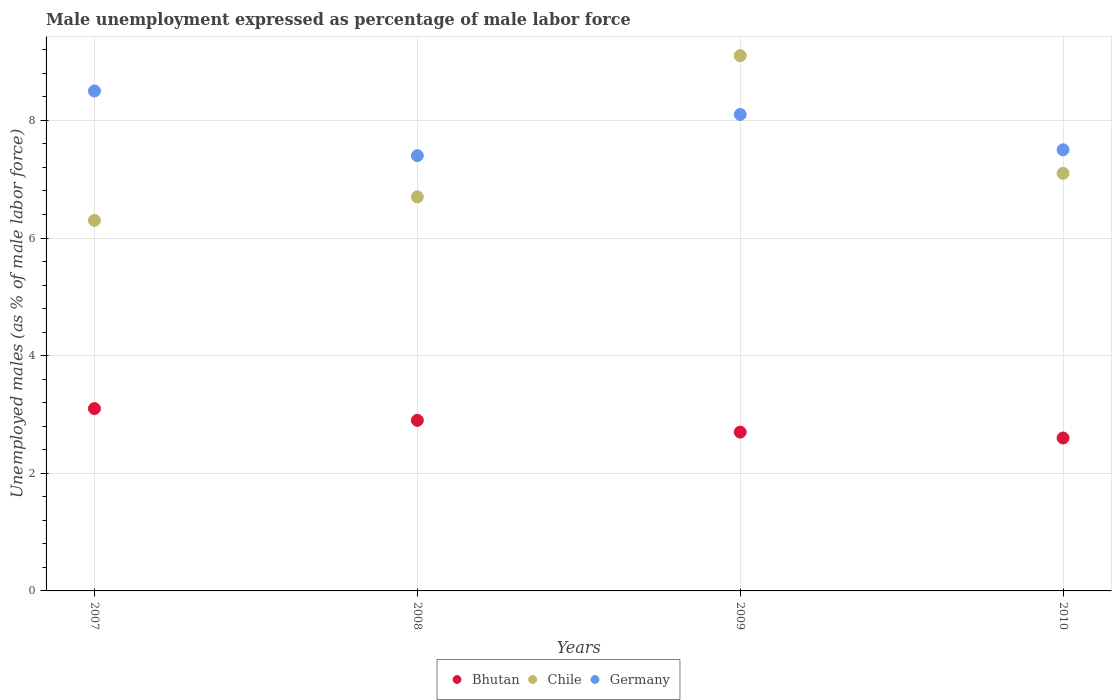Is the number of dotlines equal to the number of legend labels?
Provide a succinct answer. Yes. Across all years, what is the maximum unemployment in males in in Chile?
Your answer should be very brief. 9.1. Across all years, what is the minimum unemployment in males in in Bhutan?
Offer a very short reply. 2.6. What is the total unemployment in males in in Bhutan in the graph?
Your response must be concise. 11.3. What is the difference between the unemployment in males in in Bhutan in 2007 and that in 2009?
Keep it short and to the point. 0.4. What is the difference between the unemployment in males in in Bhutan in 2010 and the unemployment in males in in Germany in 2008?
Provide a succinct answer. -4.8. What is the average unemployment in males in in Chile per year?
Provide a short and direct response. 7.3. In the year 2010, what is the difference between the unemployment in males in in Germany and unemployment in males in in Bhutan?
Ensure brevity in your answer.  4.9. In how many years, is the unemployment in males in in Bhutan greater than 6 %?
Make the answer very short. 0. What is the ratio of the unemployment in males in in Germany in 2007 to that in 2009?
Give a very brief answer. 1.05. Is the unemployment in males in in Germany in 2007 less than that in 2008?
Give a very brief answer. No. Is the difference between the unemployment in males in in Germany in 2008 and 2009 greater than the difference between the unemployment in males in in Bhutan in 2008 and 2009?
Offer a terse response. No. What is the difference between the highest and the second highest unemployment in males in in Germany?
Provide a short and direct response. 0.4. What is the difference between the highest and the lowest unemployment in males in in Germany?
Ensure brevity in your answer.  1.1. In how many years, is the unemployment in males in in Germany greater than the average unemployment in males in in Germany taken over all years?
Your response must be concise. 2. Is the sum of the unemployment in males in in Bhutan in 2007 and 2010 greater than the maximum unemployment in males in in Chile across all years?
Offer a terse response. No. Is it the case that in every year, the sum of the unemployment in males in in Germany and unemployment in males in in Chile  is greater than the unemployment in males in in Bhutan?
Your response must be concise. Yes. Does the unemployment in males in in Germany monotonically increase over the years?
Your answer should be very brief. No. Is the unemployment in males in in Bhutan strictly less than the unemployment in males in in Chile over the years?
Your answer should be very brief. Yes. How many dotlines are there?
Keep it short and to the point. 3. What is the difference between two consecutive major ticks on the Y-axis?
Ensure brevity in your answer.  2. How are the legend labels stacked?
Your answer should be very brief. Horizontal. What is the title of the graph?
Offer a terse response. Male unemployment expressed as percentage of male labor force. What is the label or title of the X-axis?
Give a very brief answer. Years. What is the label or title of the Y-axis?
Ensure brevity in your answer.  Unemployed males (as % of male labor force). What is the Unemployed males (as % of male labor force) of Bhutan in 2007?
Give a very brief answer. 3.1. What is the Unemployed males (as % of male labor force) of Chile in 2007?
Offer a very short reply. 6.3. What is the Unemployed males (as % of male labor force) of Germany in 2007?
Offer a terse response. 8.5. What is the Unemployed males (as % of male labor force) of Bhutan in 2008?
Provide a short and direct response. 2.9. What is the Unemployed males (as % of male labor force) of Chile in 2008?
Ensure brevity in your answer.  6.7. What is the Unemployed males (as % of male labor force) in Germany in 2008?
Your response must be concise. 7.4. What is the Unemployed males (as % of male labor force) of Bhutan in 2009?
Your answer should be very brief. 2.7. What is the Unemployed males (as % of male labor force) of Chile in 2009?
Provide a succinct answer. 9.1. What is the Unemployed males (as % of male labor force) of Germany in 2009?
Keep it short and to the point. 8.1. What is the Unemployed males (as % of male labor force) of Bhutan in 2010?
Provide a short and direct response. 2.6. What is the Unemployed males (as % of male labor force) of Chile in 2010?
Make the answer very short. 7.1. Across all years, what is the maximum Unemployed males (as % of male labor force) in Bhutan?
Keep it short and to the point. 3.1. Across all years, what is the maximum Unemployed males (as % of male labor force) of Chile?
Your answer should be compact. 9.1. Across all years, what is the maximum Unemployed males (as % of male labor force) in Germany?
Offer a very short reply. 8.5. Across all years, what is the minimum Unemployed males (as % of male labor force) of Bhutan?
Offer a terse response. 2.6. Across all years, what is the minimum Unemployed males (as % of male labor force) in Chile?
Make the answer very short. 6.3. Across all years, what is the minimum Unemployed males (as % of male labor force) of Germany?
Give a very brief answer. 7.4. What is the total Unemployed males (as % of male labor force) of Chile in the graph?
Provide a succinct answer. 29.2. What is the total Unemployed males (as % of male labor force) of Germany in the graph?
Offer a terse response. 31.5. What is the difference between the Unemployed males (as % of male labor force) of Bhutan in 2007 and that in 2008?
Your response must be concise. 0.2. What is the difference between the Unemployed males (as % of male labor force) in Germany in 2007 and that in 2008?
Your answer should be very brief. 1.1. What is the difference between the Unemployed males (as % of male labor force) of Chile in 2007 and that in 2009?
Offer a very short reply. -2.8. What is the difference between the Unemployed males (as % of male labor force) of Germany in 2007 and that in 2010?
Offer a terse response. 1. What is the difference between the Unemployed males (as % of male labor force) in Germany in 2008 and that in 2009?
Make the answer very short. -0.7. What is the difference between the Unemployed males (as % of male labor force) of Bhutan in 2009 and that in 2010?
Make the answer very short. 0.1. What is the difference between the Unemployed males (as % of male labor force) of Chile in 2009 and that in 2010?
Make the answer very short. 2. What is the difference between the Unemployed males (as % of male labor force) of Chile in 2007 and the Unemployed males (as % of male labor force) of Germany in 2008?
Provide a succinct answer. -1.1. What is the difference between the Unemployed males (as % of male labor force) of Bhutan in 2007 and the Unemployed males (as % of male labor force) of Germany in 2009?
Offer a terse response. -5. What is the difference between the Unemployed males (as % of male labor force) of Chile in 2007 and the Unemployed males (as % of male labor force) of Germany in 2009?
Offer a terse response. -1.8. What is the difference between the Unemployed males (as % of male labor force) of Bhutan in 2007 and the Unemployed males (as % of male labor force) of Germany in 2010?
Give a very brief answer. -4.4. What is the difference between the Unemployed males (as % of male labor force) in Chile in 2007 and the Unemployed males (as % of male labor force) in Germany in 2010?
Your response must be concise. -1.2. What is the difference between the Unemployed males (as % of male labor force) in Bhutan in 2009 and the Unemployed males (as % of male labor force) in Chile in 2010?
Offer a very short reply. -4.4. What is the difference between the Unemployed males (as % of male labor force) in Chile in 2009 and the Unemployed males (as % of male labor force) in Germany in 2010?
Give a very brief answer. 1.6. What is the average Unemployed males (as % of male labor force) in Bhutan per year?
Ensure brevity in your answer.  2.83. What is the average Unemployed males (as % of male labor force) in Germany per year?
Provide a succinct answer. 7.88. In the year 2007, what is the difference between the Unemployed males (as % of male labor force) of Bhutan and Unemployed males (as % of male labor force) of Chile?
Provide a short and direct response. -3.2. In the year 2007, what is the difference between the Unemployed males (as % of male labor force) of Bhutan and Unemployed males (as % of male labor force) of Germany?
Your answer should be very brief. -5.4. In the year 2007, what is the difference between the Unemployed males (as % of male labor force) of Chile and Unemployed males (as % of male labor force) of Germany?
Provide a short and direct response. -2.2. In the year 2008, what is the difference between the Unemployed males (as % of male labor force) of Bhutan and Unemployed males (as % of male labor force) of Chile?
Your answer should be very brief. -3.8. In the year 2008, what is the difference between the Unemployed males (as % of male labor force) of Bhutan and Unemployed males (as % of male labor force) of Germany?
Provide a short and direct response. -4.5. In the year 2008, what is the difference between the Unemployed males (as % of male labor force) in Chile and Unemployed males (as % of male labor force) in Germany?
Offer a terse response. -0.7. In the year 2010, what is the difference between the Unemployed males (as % of male labor force) of Bhutan and Unemployed males (as % of male labor force) of Chile?
Offer a terse response. -4.5. In the year 2010, what is the difference between the Unemployed males (as % of male labor force) in Chile and Unemployed males (as % of male labor force) in Germany?
Offer a very short reply. -0.4. What is the ratio of the Unemployed males (as % of male labor force) of Bhutan in 2007 to that in 2008?
Your answer should be very brief. 1.07. What is the ratio of the Unemployed males (as % of male labor force) in Chile in 2007 to that in 2008?
Make the answer very short. 0.94. What is the ratio of the Unemployed males (as % of male labor force) in Germany in 2007 to that in 2008?
Offer a very short reply. 1.15. What is the ratio of the Unemployed males (as % of male labor force) of Bhutan in 2007 to that in 2009?
Your answer should be very brief. 1.15. What is the ratio of the Unemployed males (as % of male labor force) in Chile in 2007 to that in 2009?
Your answer should be compact. 0.69. What is the ratio of the Unemployed males (as % of male labor force) in Germany in 2007 to that in 2009?
Make the answer very short. 1.05. What is the ratio of the Unemployed males (as % of male labor force) of Bhutan in 2007 to that in 2010?
Ensure brevity in your answer.  1.19. What is the ratio of the Unemployed males (as % of male labor force) of Chile in 2007 to that in 2010?
Your answer should be very brief. 0.89. What is the ratio of the Unemployed males (as % of male labor force) in Germany in 2007 to that in 2010?
Give a very brief answer. 1.13. What is the ratio of the Unemployed males (as % of male labor force) in Bhutan in 2008 to that in 2009?
Your response must be concise. 1.07. What is the ratio of the Unemployed males (as % of male labor force) in Chile in 2008 to that in 2009?
Provide a short and direct response. 0.74. What is the ratio of the Unemployed males (as % of male labor force) in Germany in 2008 to that in 2009?
Your response must be concise. 0.91. What is the ratio of the Unemployed males (as % of male labor force) in Bhutan in 2008 to that in 2010?
Your response must be concise. 1.12. What is the ratio of the Unemployed males (as % of male labor force) in Chile in 2008 to that in 2010?
Keep it short and to the point. 0.94. What is the ratio of the Unemployed males (as % of male labor force) of Germany in 2008 to that in 2010?
Make the answer very short. 0.99. What is the ratio of the Unemployed males (as % of male labor force) of Chile in 2009 to that in 2010?
Make the answer very short. 1.28. What is the ratio of the Unemployed males (as % of male labor force) in Germany in 2009 to that in 2010?
Make the answer very short. 1.08. What is the difference between the highest and the second highest Unemployed males (as % of male labor force) of Bhutan?
Your answer should be compact. 0.2. What is the difference between the highest and the second highest Unemployed males (as % of male labor force) in Chile?
Keep it short and to the point. 2. What is the difference between the highest and the second highest Unemployed males (as % of male labor force) of Germany?
Offer a terse response. 0.4. What is the difference between the highest and the lowest Unemployed males (as % of male labor force) of Germany?
Ensure brevity in your answer.  1.1. 